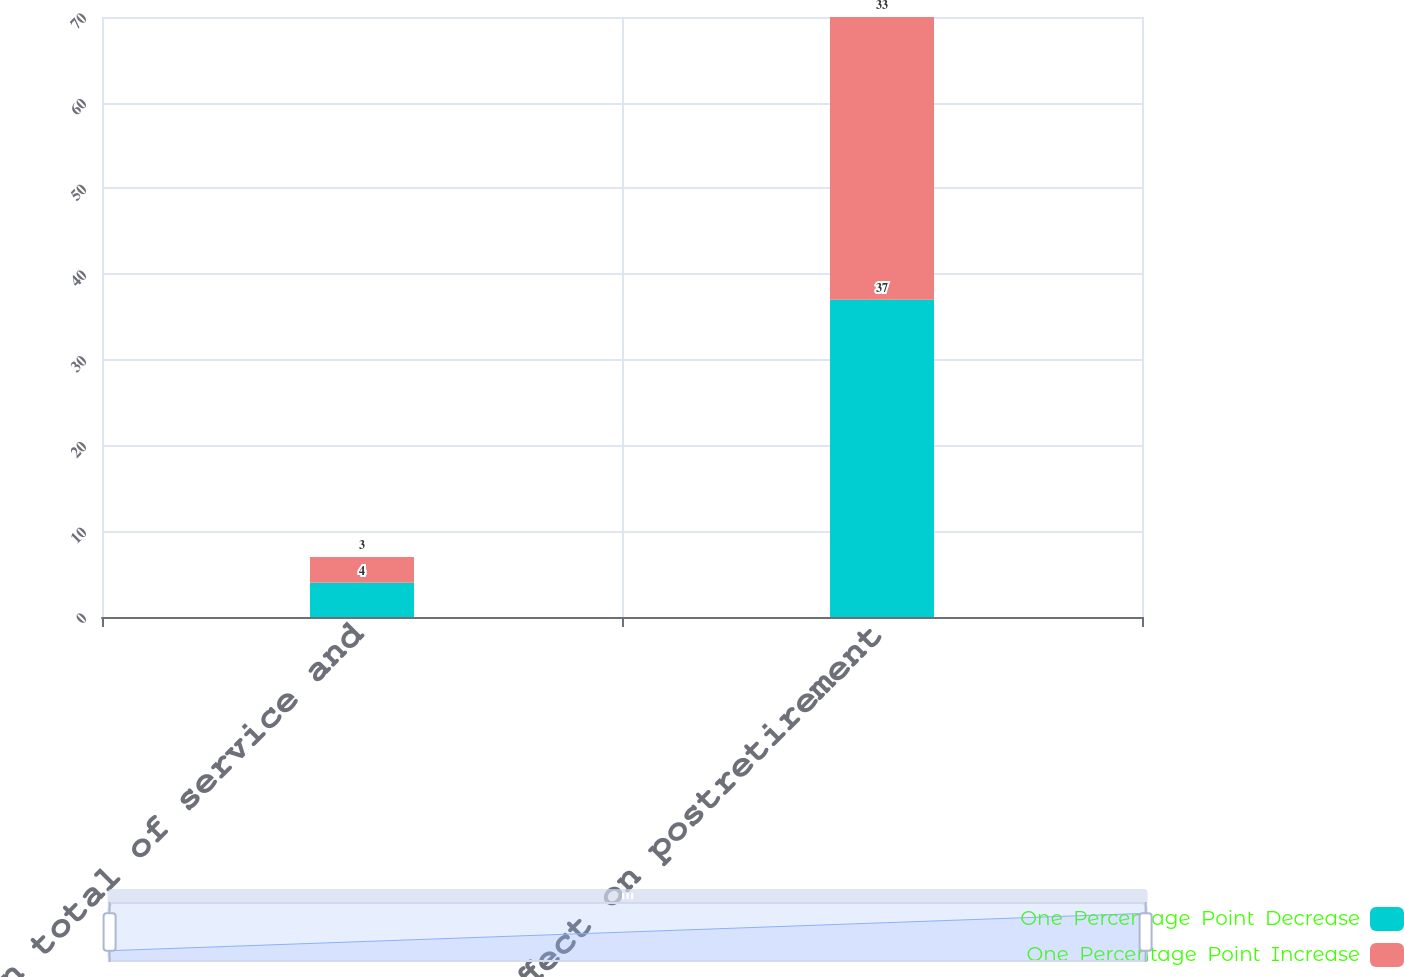Convert chart. <chart><loc_0><loc_0><loc_500><loc_500><stacked_bar_chart><ecel><fcel>Effect on total of service and<fcel>Effect on postretirement<nl><fcel>One  Percentage  Point  Decrease<fcel>4<fcel>37<nl><fcel>One  Percentage  Point  Increase<fcel>3<fcel>33<nl></chart> 